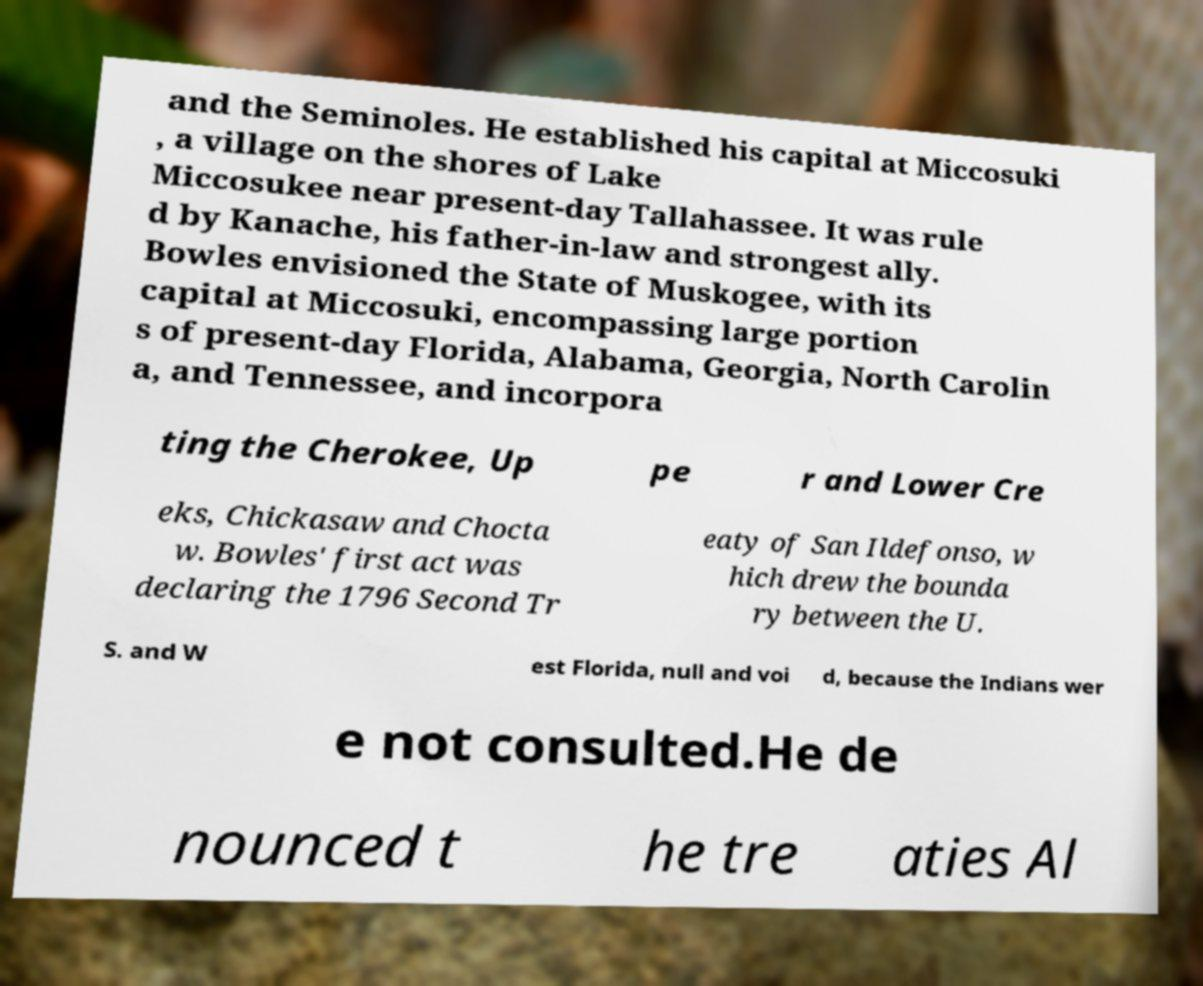Could you extract and type out the text from this image? and the Seminoles. He established his capital at Miccosuki , a village on the shores of Lake Miccosukee near present-day Tallahassee. It was rule d by Kanache, his father-in-law and strongest ally. Bowles envisioned the State of Muskogee, with its capital at Miccosuki, encompassing large portion s of present-day Florida, Alabama, Georgia, North Carolin a, and Tennessee, and incorpora ting the Cherokee, Up pe r and Lower Cre eks, Chickasaw and Chocta w. Bowles' first act was declaring the 1796 Second Tr eaty of San Ildefonso, w hich drew the bounda ry between the U. S. and W est Florida, null and voi d, because the Indians wer e not consulted.He de nounced t he tre aties Al 